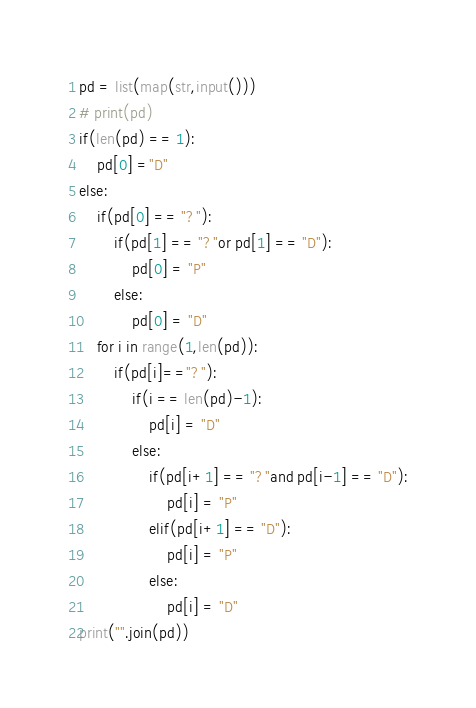Convert code to text. <code><loc_0><loc_0><loc_500><loc_500><_Python_>pd = list(map(str,input()))
# print(pd)
if(len(pd) == 1):
    pd[0] ="D"
else:
    if(pd[0] == "?"):
        if(pd[1] == "?"or pd[1] == "D"):
            pd[0] = "P"
        else:
            pd[0] = "D"
    for i in range(1,len(pd)):
        if(pd[i]=="?"):
            if(i == len(pd)-1):
                pd[i] = "D"
            else:            
                if(pd[i+1] == "?"and pd[i-1] == "D"):
                    pd[i] = "P"
                elif(pd[i+1] == "D"):
                    pd[i] = "P"
                else:
                    pd[i] = "D"
print("".join(pd))</code> 